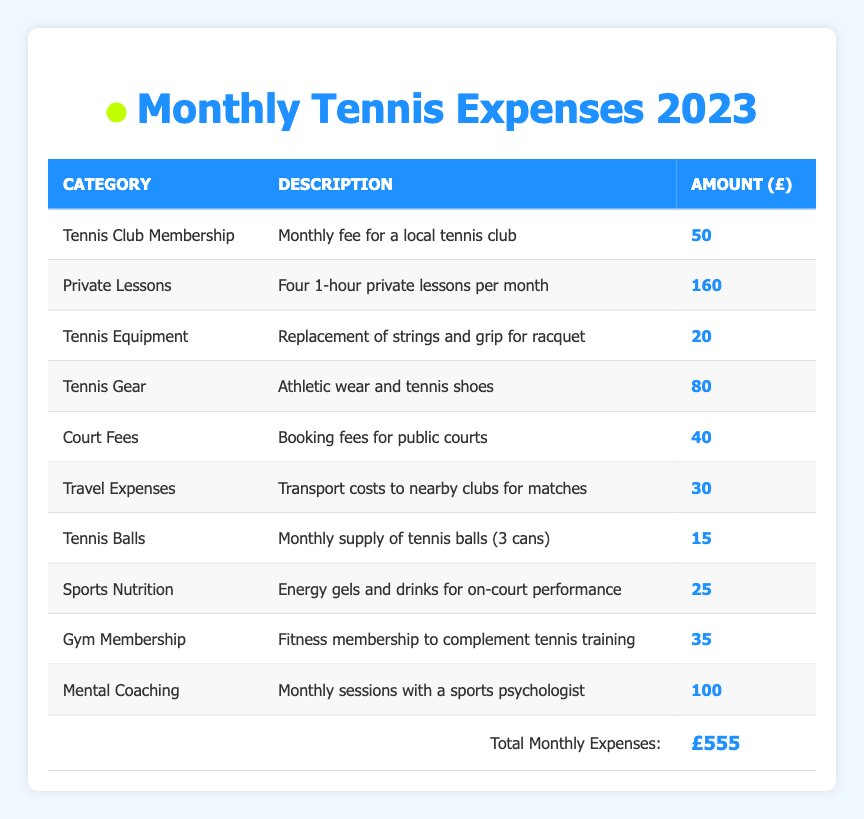What is the most expensive monthly expense for a tennis enthusiast? The table lists various expenses, and the highest amount is found under the "Private Lessons" category, which is £160.
Answer: £160 What is the total monthly expense when combining the costs of "Tennis Club Membership," "Gym Membership," and "Tennis Balls"? First, I add the three amounts: Tennis Club Membership (£50) + Gym Membership (£35) + Tennis Balls (£15) = £100.
Answer: £100 Are the "Court Fees" more expensive than the "Tennis Equipment"? The Court Fees amount to £40 and the Tennis Equipment costs £20. Since £40 is greater than £20, the statement is true.
Answer: Yes What is the total amount spent on lessons and mental coaching in a month? To find this, I sum the costs of Private Lessons (£160) and Mental Coaching (£100). The total is £160 + £100 = £260.
Answer: £260 If I were to eliminate the expense of "Tennis Gear," what would the new total monthly expense be? The original total monthly expenses amount to £555. If we subtract the Tennis Gear expense of £80, the new total would be £555 - £80 = £475.
Answer: £475 What is the average cost of Sports Nutrition, Tennis Balls, and Tennis Equipment? First, I find the total for these expenses: Sports Nutrition (£25) + Tennis Balls (£15) + Tennis Equipment (£20) = £60. There are three items, so the average is £60 / 3 = £20.
Answer: £20 Which category has the least amount spent monthly? By reviewing the table, "Tennis Balls" at £15 has the lowest value among all categories.
Answer: £15 What percentage of the total expenses is spent on "Private Lessons"? The total monthly expenses are £555, and "Private Lessons" is £160. To find the percentage, I calculate (£160 / £555) * 100, which gives approximately 28.83%.
Answer: Approximately 28.83% How much more is spent monthly on "Mental Coaching" compared to "Tennis Equipment"? The amount spent on Mental Coaching is £100, while Tennis Equipment costs £20. Therefore, the difference is £100 - £20 = £80.
Answer: £80 If I want to spend the same amount on "Travel Expenses" and "Tennis Balls," how much will I need to budget for both? The Travel Expenses are £30 and Tennis Balls are £15. The combined budget needed would be £30 + £15 = £45.
Answer: £45 